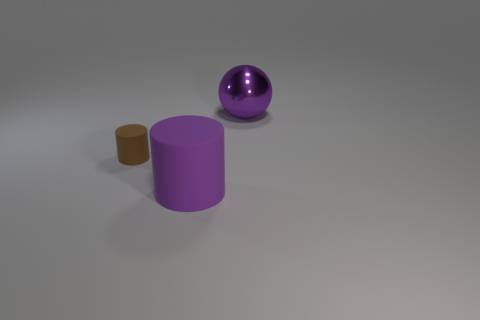Add 3 big objects. How many objects exist? 6 Subtract all balls. How many objects are left? 2 Add 3 big cylinders. How many big cylinders are left? 4 Add 1 tiny matte objects. How many tiny matte objects exist? 2 Subtract 0 green cylinders. How many objects are left? 3 Subtract all cylinders. Subtract all large spheres. How many objects are left? 0 